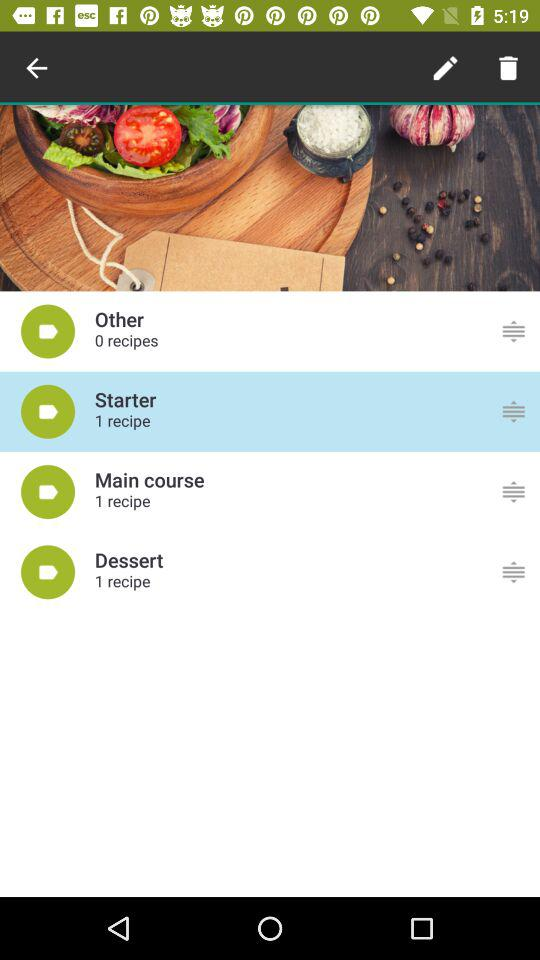What is the number of recipes in the main course? The number of recipes in the main course is "1". 